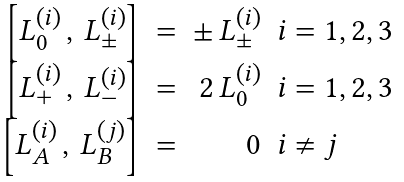<formula> <loc_0><loc_0><loc_500><loc_500>\begin{array} { r c r l } \left [ L ^ { ( i ) } _ { 0 } \, , \, L ^ { ( i ) } _ { \pm } \right ] & = & \pm \, L ^ { ( i ) } _ { \pm } & i = 1 , 2 , 3 \\ \left [ L ^ { ( i ) } _ { + } \, , \, L ^ { ( i ) } _ { - } \right ] & = & 2 \, L ^ { ( i ) } _ { 0 } & i = 1 , 2 , 3 \\ \left [ L ^ { ( i ) } _ { A } \, , \, L ^ { ( j ) } _ { B } \right ] & = & 0 & i \neq j \\ \end{array}</formula> 